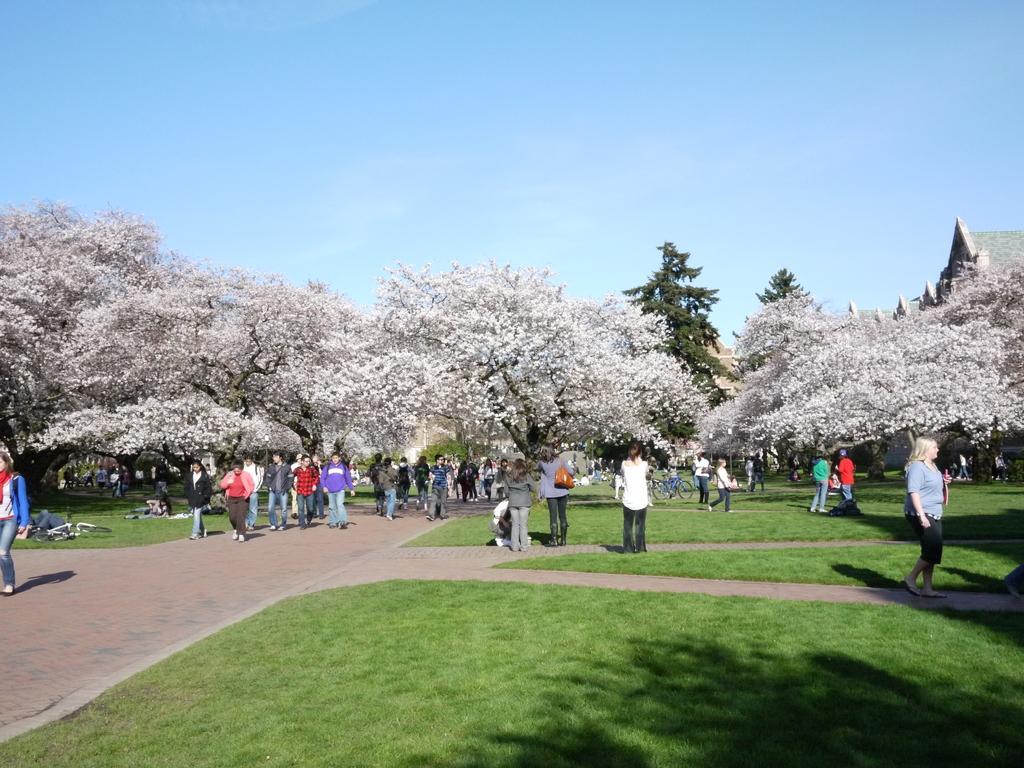In one or two sentences, can you explain what this image depicts? In this image there are many people walking on the ground. Beside them there's grass on the ground. In the background there are trees and houses. At the top there is the sky. 